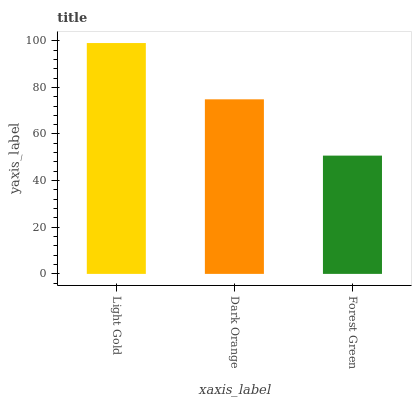Is Forest Green the minimum?
Answer yes or no. Yes. Is Light Gold the maximum?
Answer yes or no. Yes. Is Dark Orange the minimum?
Answer yes or no. No. Is Dark Orange the maximum?
Answer yes or no. No. Is Light Gold greater than Dark Orange?
Answer yes or no. Yes. Is Dark Orange less than Light Gold?
Answer yes or no. Yes. Is Dark Orange greater than Light Gold?
Answer yes or no. No. Is Light Gold less than Dark Orange?
Answer yes or no. No. Is Dark Orange the high median?
Answer yes or no. Yes. Is Dark Orange the low median?
Answer yes or no. Yes. Is Forest Green the high median?
Answer yes or no. No. Is Light Gold the low median?
Answer yes or no. No. 